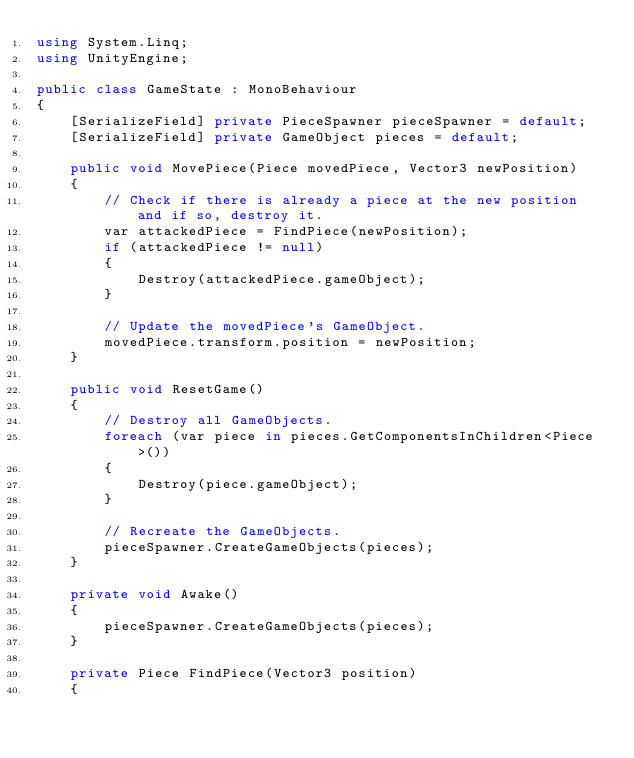Convert code to text. <code><loc_0><loc_0><loc_500><loc_500><_C#_>using System.Linq;
using UnityEngine;

public class GameState : MonoBehaviour
{
    [SerializeField] private PieceSpawner pieceSpawner = default;
    [SerializeField] private GameObject pieces = default;

    public void MovePiece(Piece movedPiece, Vector3 newPosition)
    {
        // Check if there is already a piece at the new position and if so, destroy it.
        var attackedPiece = FindPiece(newPosition);
        if (attackedPiece != null)
        {
            Destroy(attackedPiece.gameObject);
        }

        // Update the movedPiece's GameObject.
        movedPiece.transform.position = newPosition;
    }

    public void ResetGame()
    {
        // Destroy all GameObjects.
        foreach (var piece in pieces.GetComponentsInChildren<Piece>())
        {
            Destroy(piece.gameObject);
        }

        // Recreate the GameObjects.
        pieceSpawner.CreateGameObjects(pieces);
    }

    private void Awake()
    {
        pieceSpawner.CreateGameObjects(pieces);
    }

    private Piece FindPiece(Vector3 position)
    {</code> 